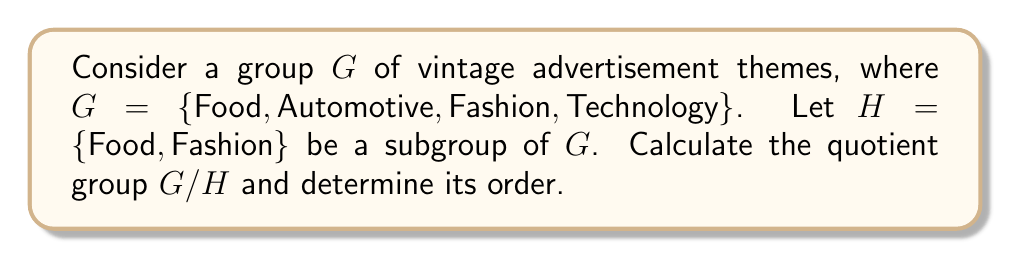Give your solution to this math problem. To calculate the quotient group $G/H$, we need to follow these steps:

1) First, recall that the quotient group $G/H$ consists of all cosets of $H$ in $G$.

2) The cosets are calculated by multiplying each element of $G$ by $H$:

   $\text{Food} \cdot H = \{\text{Food}, \text{Fashion}\} = H$
   $\text{Automotive} \cdot H = \{\text{Automotive}, \text{Automotive}\} = \text{Automotive}H$
   $\text{Fashion} \cdot H = \{\text{Fashion}, \text{Food}\} = H$
   $\text{Technology} \cdot H = \{\text{Technology}, \text{Technology}\} = \text{Technology}H$

3) We can see that there are two distinct cosets:
   $H = \{\text{Food}, \text{Fashion}\}$
   $\text{Automotive}H = \{\text{Automotive}, \text{Technology}\}$

4) Therefore, the quotient group $G/H = \{H, \text{Automotive}H\}$

5) The order of a quotient group is given by the formula:

   $|G/H| = \frac{|G|}{|H|}$

   Where $|G|$ is the order of $G$ and $|H|$ is the order of $H$.

6) In this case, $|G| = 4$ and $|H| = 2$, so:

   $|G/H| = \frac{4}{2} = 2$

This result aligns with our calculation in step 4, where we found two distinct cosets.
Answer: The quotient group $G/H = \{H, \text{Automotive}H\}$, and its order is $|G/H| = 2$. 